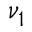<formula> <loc_0><loc_0><loc_500><loc_500>\nu _ { 1 }</formula> 